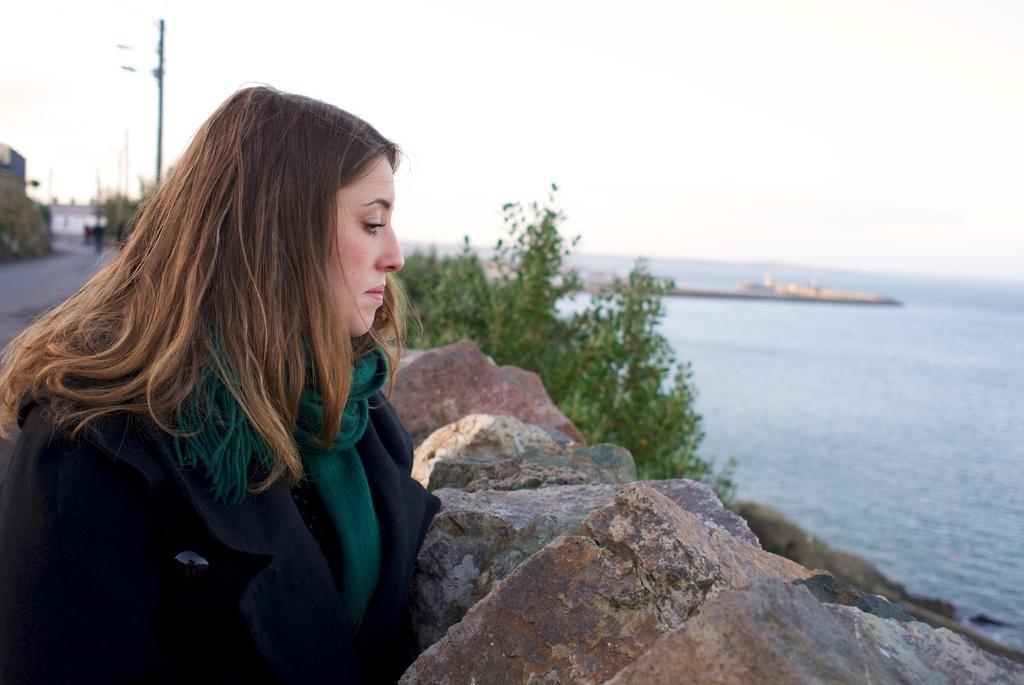Could you give a brief overview of what you see in this image? On the left side of the image we can see woman standing at the stones. In the background there are trees, water, ship, building, poles and sky. 